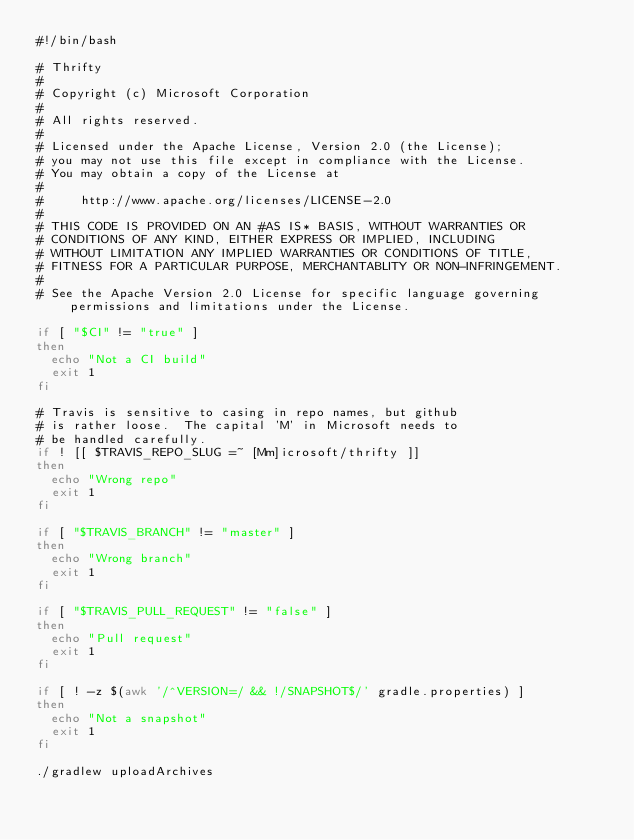<code> <loc_0><loc_0><loc_500><loc_500><_Bash_>#!/bin/bash

# Thrifty
#
# Copyright (c) Microsoft Corporation
#
# All rights reserved.
#
# Licensed under the Apache License, Version 2.0 (the License);
# you may not use this file except in compliance with the License.
# You may obtain a copy of the License at
#
#     http://www.apache.org/licenses/LICENSE-2.0
#
# THIS CODE IS PROVIDED ON AN #AS IS* BASIS, WITHOUT WARRANTIES OR
# CONDITIONS OF ANY KIND, EITHER EXPRESS OR IMPLIED, INCLUDING
# WITHOUT LIMITATION ANY IMPLIED WARRANTIES OR CONDITIONS OF TITLE,
# FITNESS FOR A PARTICULAR PURPOSE, MERCHANTABLITY OR NON-INFRINGEMENT.
#
# See the Apache Version 2.0 License for specific language governing permissions and limitations under the License.

if [ "$CI" != "true" ]
then
  echo "Not a CI build"
  exit 1
fi

# Travis is sensitive to casing in repo names, but github
# is rather loose.  The capital 'M' in Microsoft needs to
# be handled carefully.
if ! [[ $TRAVIS_REPO_SLUG =~ [Mm]icrosoft/thrifty ]]
then
  echo "Wrong repo"
  exit 1
fi

if [ "$TRAVIS_BRANCH" != "master" ]
then
  echo "Wrong branch"
  exit 1
fi

if [ "$TRAVIS_PULL_REQUEST" != "false" ]
then
  echo "Pull request"
  exit 1
fi

if [ ! -z $(awk '/^VERSION=/ && !/SNAPSHOT$/' gradle.properties) ]
then
  echo "Not a snapshot"
  exit 1
fi

./gradlew uploadArchives

</code> 